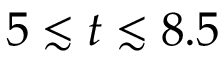<formula> <loc_0><loc_0><loc_500><loc_500>5 \lesssim t \lesssim 8 . 5</formula> 